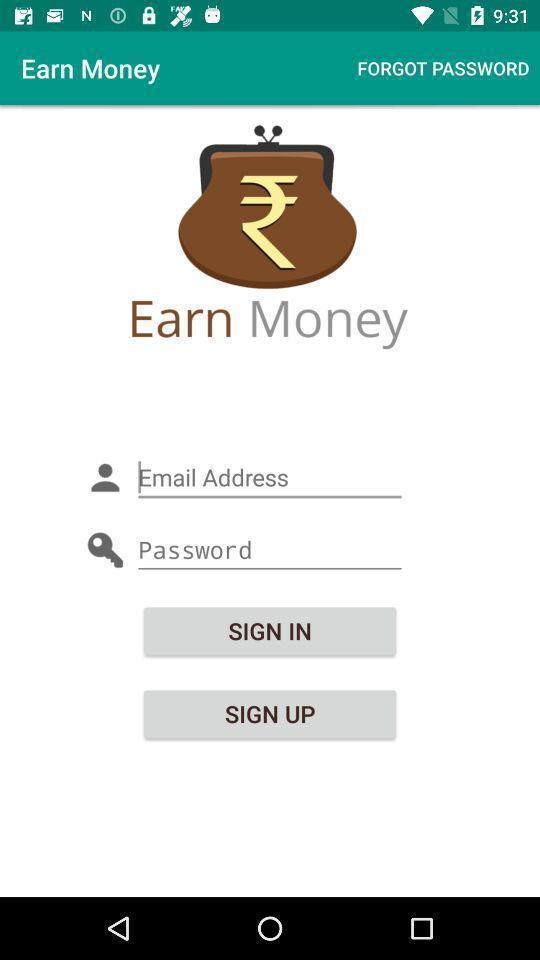What details can you identify in this image? Sign in or sign up page of an app. 